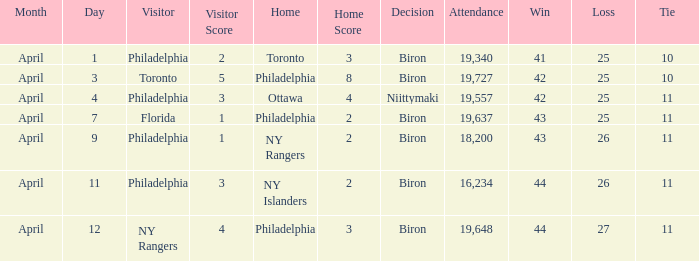Who were the visitors when the home team were the ny rangers? Philadelphia. 